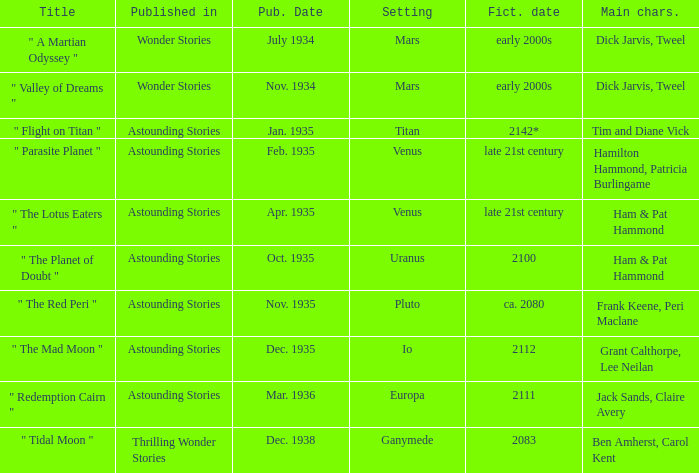Name the publication date when the fictional date is 2112 Dec. 1935. 